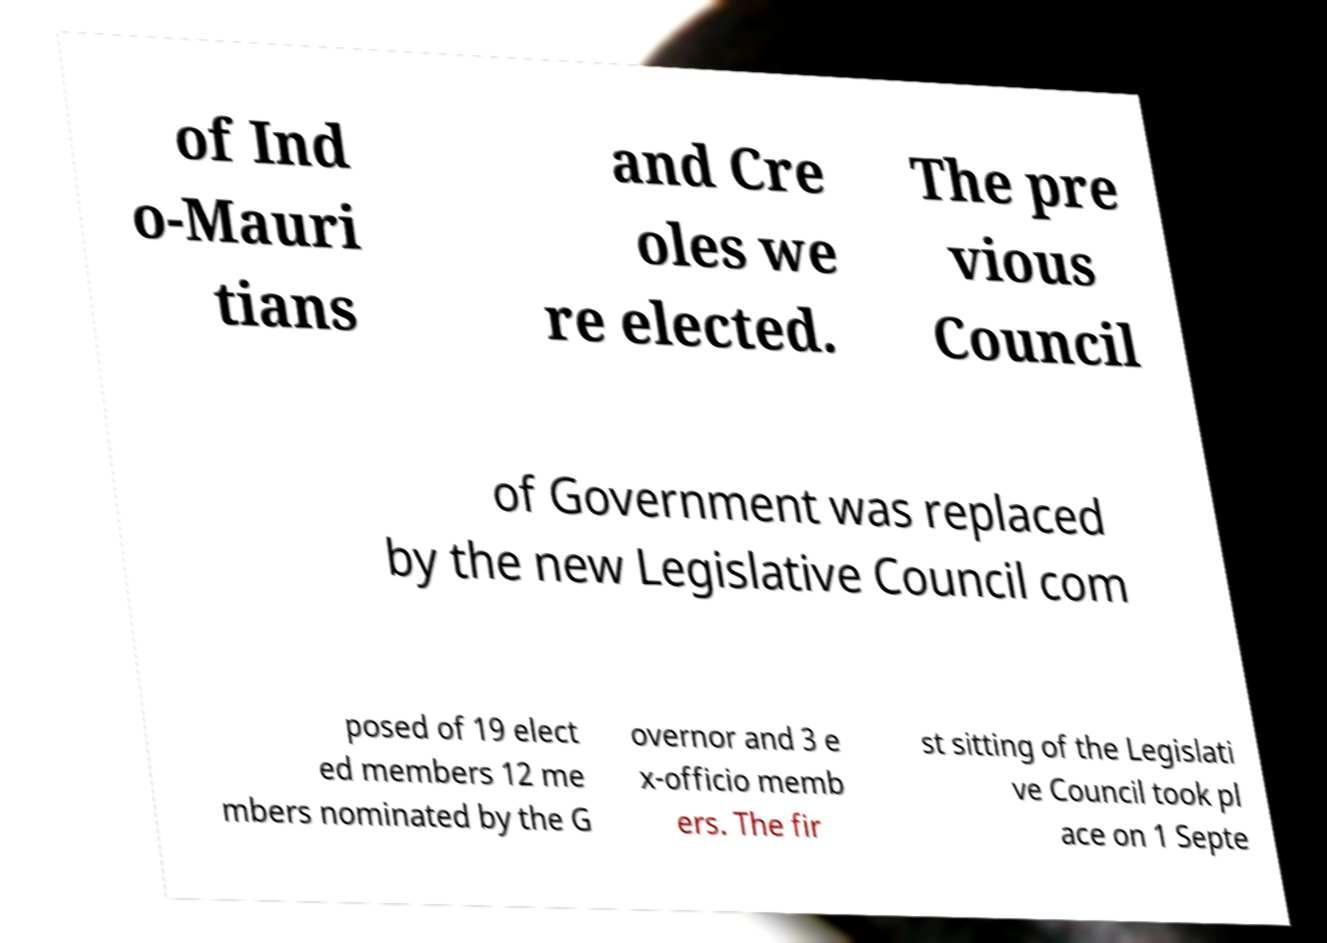There's text embedded in this image that I need extracted. Can you transcribe it verbatim? of Ind o-Mauri tians and Cre oles we re elected. The pre vious Council of Government was replaced by the new Legislative Council com posed of 19 elect ed members 12 me mbers nominated by the G overnor and 3 e x-officio memb ers. The fir st sitting of the Legislati ve Council took pl ace on 1 Septe 